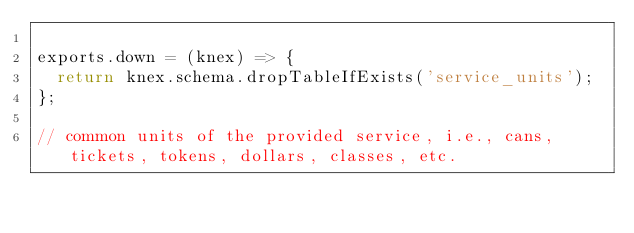<code> <loc_0><loc_0><loc_500><loc_500><_JavaScript_>
exports.down = (knex) => {
  return knex.schema.dropTableIfExists('service_units');
};

// common units of the provided service, i.e., cans, tickets, tokens, dollars, classes, etc.
</code> 